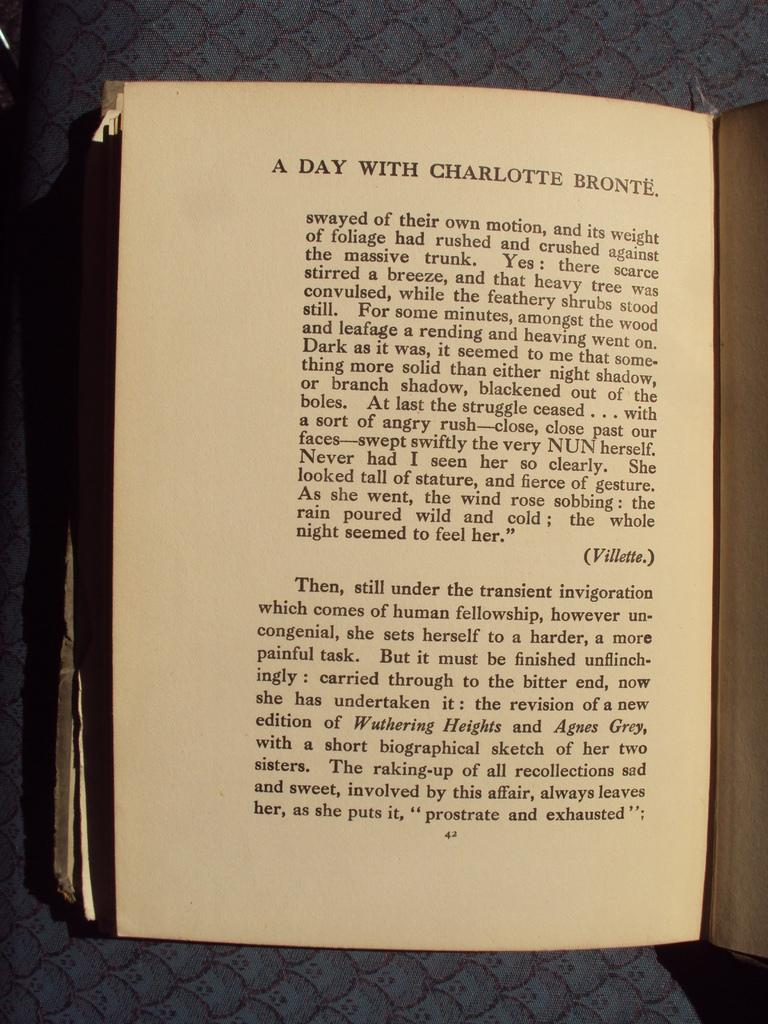<image>
Render a clear and concise summary of the photo. A page of text with the title "A Day with Charlotte Bronte." 